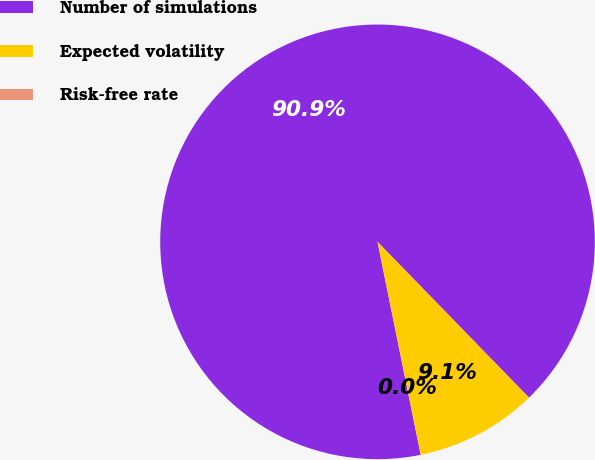Convert chart. <chart><loc_0><loc_0><loc_500><loc_500><pie_chart><fcel>Number of simulations<fcel>Expected volatility<fcel>Risk-free rate<nl><fcel>90.9%<fcel>9.09%<fcel>0.0%<nl></chart> 